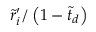Convert formula to latex. <formula><loc_0><loc_0><loc_500><loc_500>\tilde { r } _ { i } ^ { \prime } / \left ( 1 - \tilde { t } _ { d } \right )</formula> 